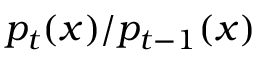<formula> <loc_0><loc_0><loc_500><loc_500>p _ { t } ( x ) / p _ { t - 1 } ( x )</formula> 